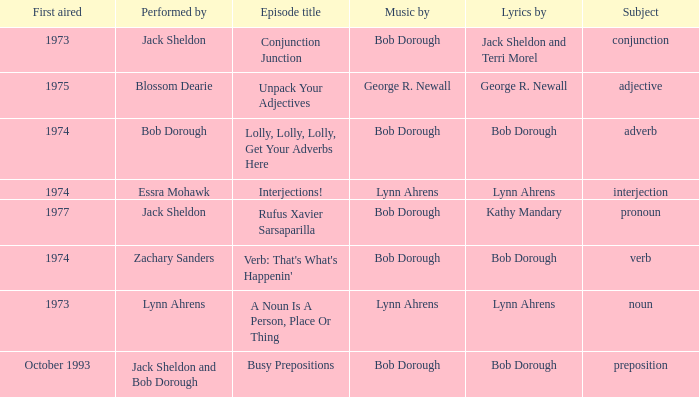When conjunction junction is the episode title and the music is by bob dorough who is the performer? Jack Sheldon. 